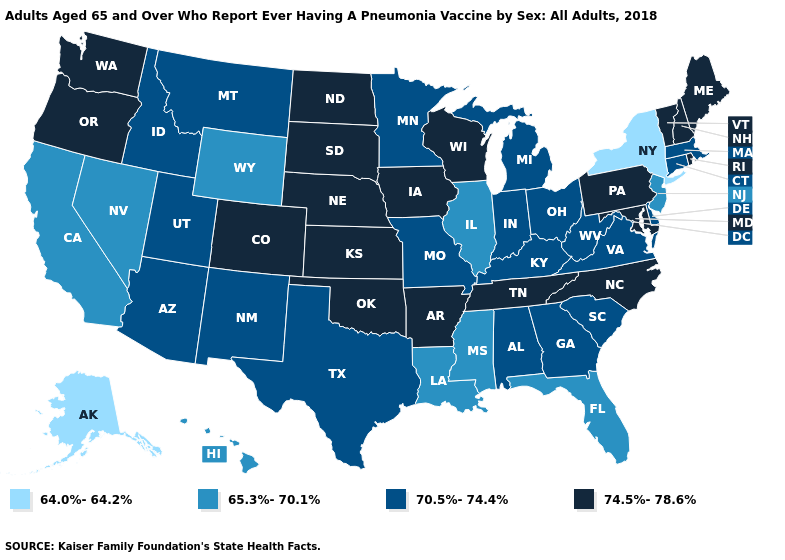What is the highest value in states that border Maryland?
Keep it brief. 74.5%-78.6%. What is the lowest value in the MidWest?
Quick response, please. 65.3%-70.1%. What is the value of Georgia?
Keep it brief. 70.5%-74.4%. What is the value of North Dakota?
Be succinct. 74.5%-78.6%. What is the highest value in the USA?
Short answer required. 74.5%-78.6%. Among the states that border Nevada , which have the lowest value?
Give a very brief answer. California. Among the states that border Wyoming , does South Dakota have the highest value?
Quick response, please. Yes. What is the highest value in the West ?
Answer briefly. 74.5%-78.6%. What is the value of North Dakota?
Give a very brief answer. 74.5%-78.6%. What is the value of Vermont?
Be succinct. 74.5%-78.6%. What is the lowest value in the USA?
Quick response, please. 64.0%-64.2%. Which states have the lowest value in the Northeast?
Be succinct. New York. Does Rhode Island have a higher value than Alabama?
Short answer required. Yes. What is the value of Alaska?
Short answer required. 64.0%-64.2%. What is the value of Tennessee?
Quick response, please. 74.5%-78.6%. 